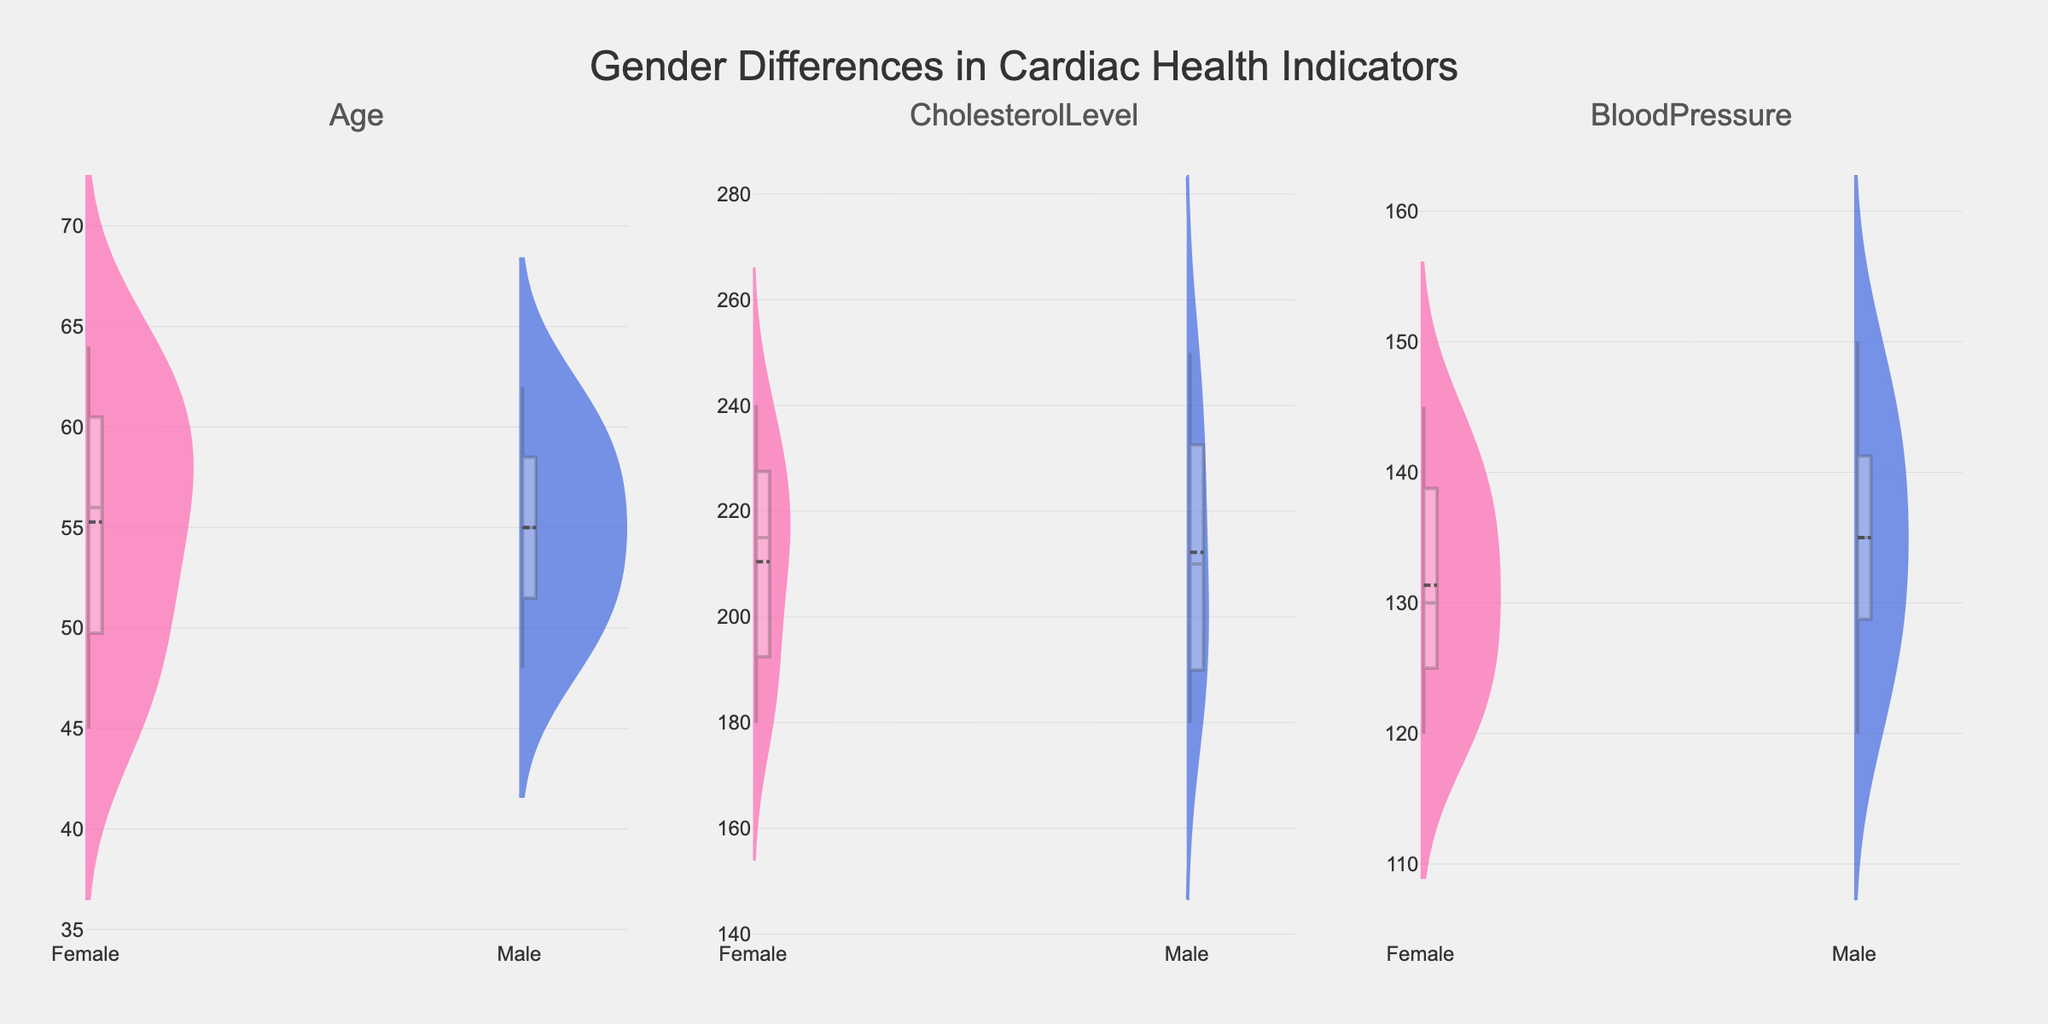What's the title of the figure? The title is located at the top of the plot. It provides an overview of what the figure represents by summarizing the content in a few words.
Answer: Gender Differences in Cardiac Health Indicators How many numeric health indicators are compared between genders in this figure? The subplot titles serve as a guide to identifying the health indicators analyzed. There are three numeric health indicators visualized on three separate subplots.
Answer: Three What colors are used to represent males and females in this plot? The colors can be identified from the violins' fill and line colors. Females are represented by a pink color, and males by a blue color.
Answer: Pink for females and blue for males What is the range of ages compared for both genders? Looking at the x-axes in the age subplot, we can estimate the range of ages visualized. The age ranges from the youngest to the oldest values observed on the plot.
Answer: Approximately 45 to 64 Which gender has a higher median Cholesterol Level? The median value can be found by looking at the middle line within the boxes of the violins in the Cholesterol Level subplot. Comparing the medians indicated by these lines will show which gender has a higher median.
Answer: Males Which gender has a wider range of Blood Pressure values? The range of Blood Pressure can be determined by observing the spread of the violins in the Blood Pressure subplot. The gender with a greater spread indicates a wider range of values.
Answer: Males What is the maximum Cholesterol Level for males? The maximum value can be found by looking at the uppermost tip of the violins in the Cholesterol Level subplot for the male group.
Answer: 250 Are females more likely to have higher Blood Pressure than males? By comparing the density and height of the female and male violins in the Blood Pressure subplot, you can observe which gender tends to have higher values more frequently.
Answer: No Compare the variability in Age between males and females. Variability can be assessed by comparing the spread (width) of the violins in the Age subplot. Wider violins indicate higher variability.
Answer: Similar In which health indicator do males show the least overlap with females? Observe where the violin plots for males and females overlap the least in the subplots for Age, Cholesterol Level, and Blood Pressure. Determine the indicator with the minimal overlap.
Answer: Cholesterol Level 